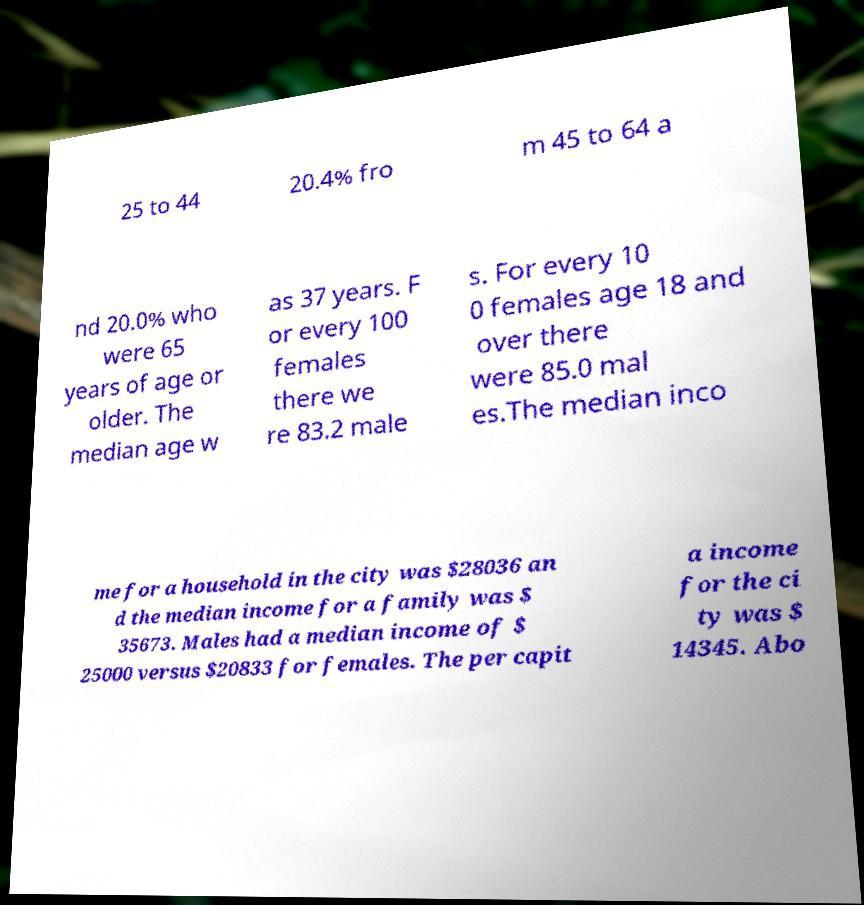There's text embedded in this image that I need extracted. Can you transcribe it verbatim? 25 to 44 20.4% fro m 45 to 64 a nd 20.0% who were 65 years of age or older. The median age w as 37 years. F or every 100 females there we re 83.2 male s. For every 10 0 females age 18 and over there were 85.0 mal es.The median inco me for a household in the city was $28036 an d the median income for a family was $ 35673. Males had a median income of $ 25000 versus $20833 for females. The per capit a income for the ci ty was $ 14345. Abo 